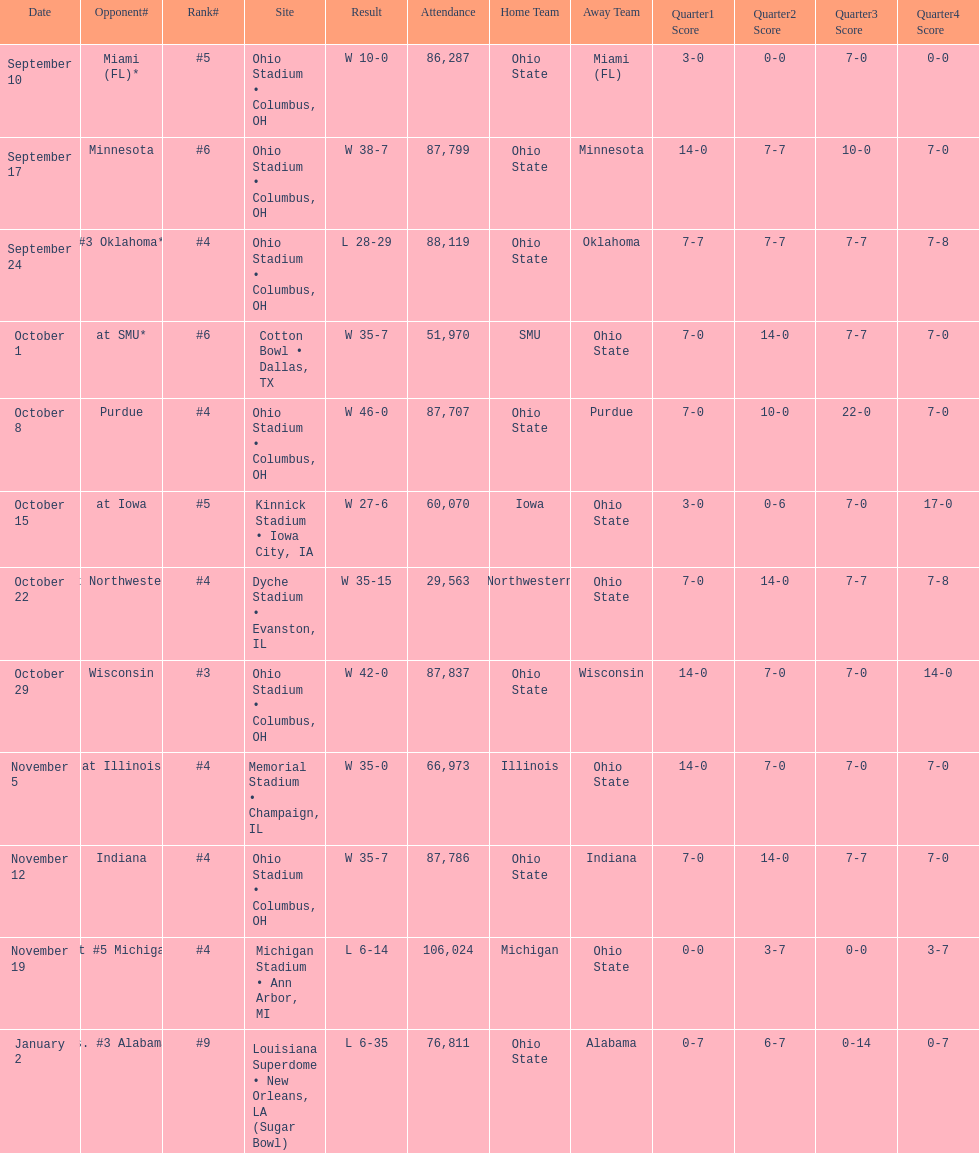What was the most recent game attended by less than 30,000 individuals? October 22. 